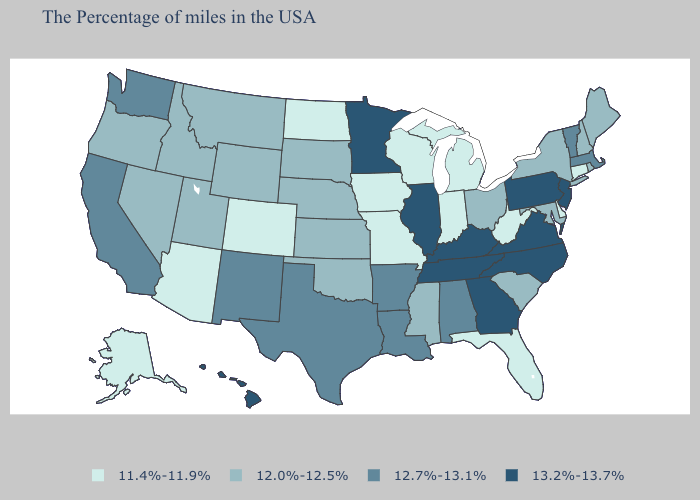Name the states that have a value in the range 13.2%-13.7%?
Keep it brief. New Jersey, Pennsylvania, Virginia, North Carolina, Georgia, Kentucky, Tennessee, Illinois, Minnesota, Hawaii. Name the states that have a value in the range 13.2%-13.7%?
Short answer required. New Jersey, Pennsylvania, Virginia, North Carolina, Georgia, Kentucky, Tennessee, Illinois, Minnesota, Hawaii. Does Hawaii have the lowest value in the USA?
Concise answer only. No. Name the states that have a value in the range 12.0%-12.5%?
Be succinct. Maine, Rhode Island, New Hampshire, New York, Maryland, South Carolina, Ohio, Mississippi, Kansas, Nebraska, Oklahoma, South Dakota, Wyoming, Utah, Montana, Idaho, Nevada, Oregon. What is the value of Oregon?
Answer briefly. 12.0%-12.5%. Does Louisiana have a higher value than Nevada?
Write a very short answer. Yes. What is the lowest value in states that border Minnesota?
Concise answer only. 11.4%-11.9%. Name the states that have a value in the range 12.7%-13.1%?
Be succinct. Massachusetts, Vermont, Alabama, Louisiana, Arkansas, Texas, New Mexico, California, Washington. How many symbols are there in the legend?
Write a very short answer. 4. Among the states that border Indiana , does Ohio have the lowest value?
Answer briefly. No. Does Rhode Island have the lowest value in the USA?
Concise answer only. No. What is the value of Kansas?
Be succinct. 12.0%-12.5%. Which states have the lowest value in the West?
Quick response, please. Colorado, Arizona, Alaska. Among the states that border Indiana , which have the highest value?
Keep it brief. Kentucky, Illinois. 